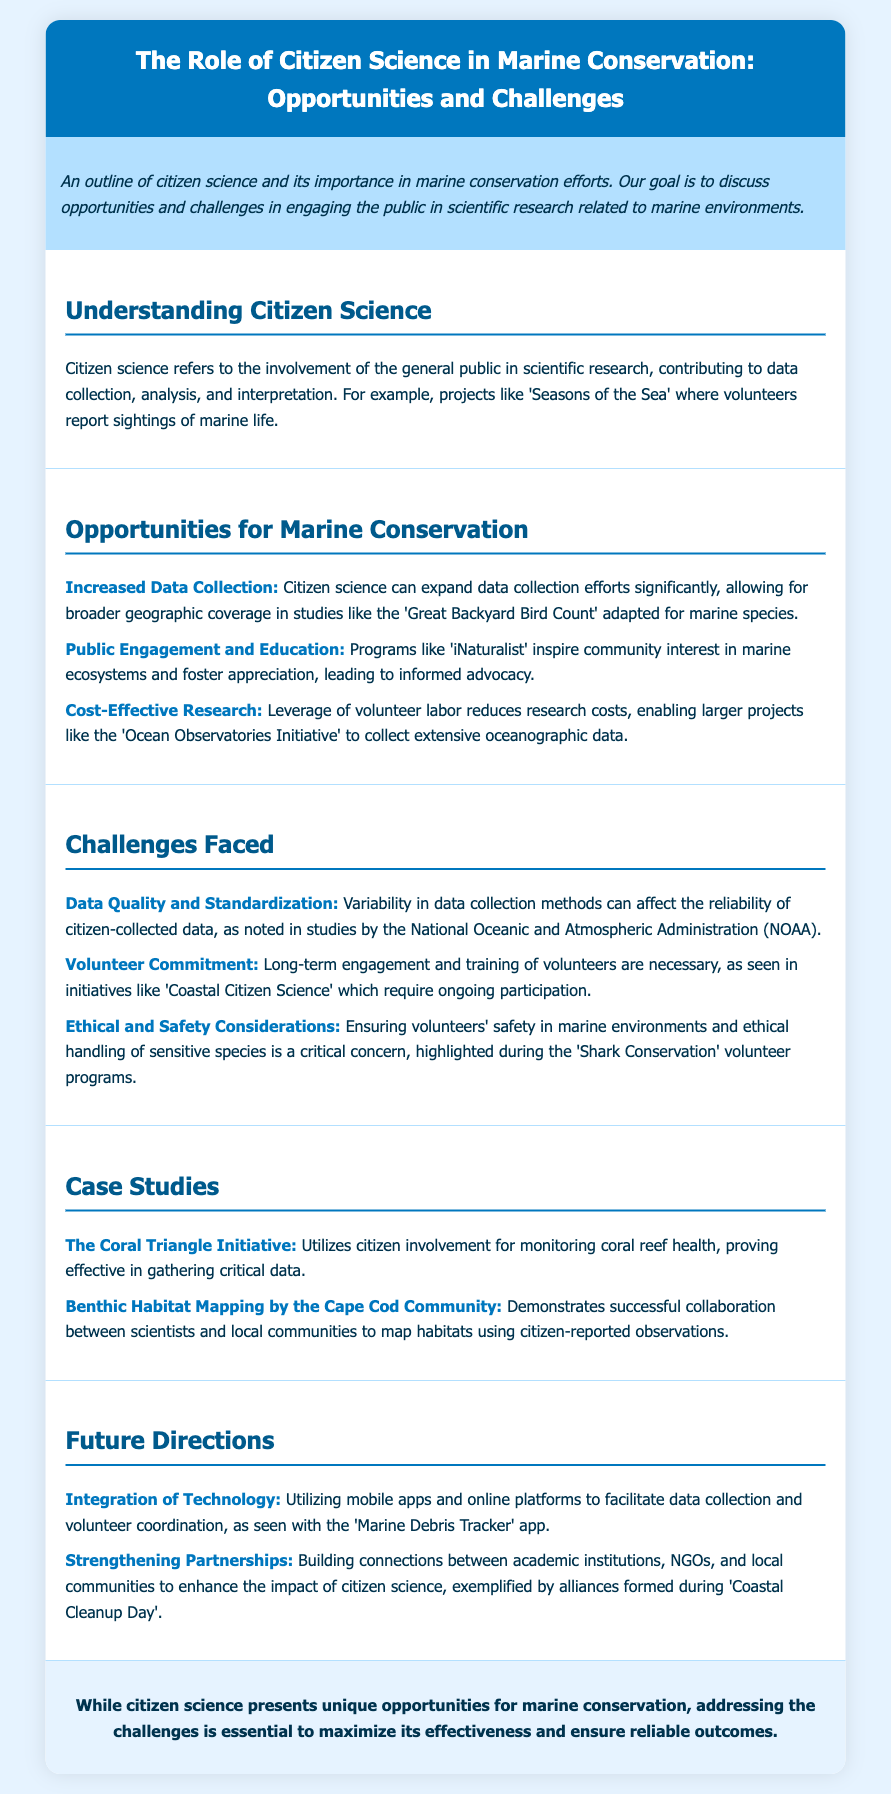What is the title of the document? The title is explicitly stated at the top of the document as "The Role of Citizen Science in Marine Conservation: Opportunities and Challenges."
Answer: The Role of Citizen Science in Marine Conservation: Opportunities and Challenges What is citizen science? The document defines citizen science as the involvement of the general public in scientific research, contributing to data collection, analysis, and interpretation.
Answer: Involvement of the general public in scientific research What are two benefits of citizen science mentioned? The document lists multiple benefits including Increased Data Collection, Public Engagement and Education, and Cost-Effective Research; two are requested.
Answer: Increased Data Collection, Public Engagement and Education Which initiative is highlighted for data quality concerns? The document specifically mentions the National Oceanic and Atmospheric Administration (NOAA) regarding data quality variability in citizen-collected data.
Answer: National Oceanic and Atmospheric Administration (NOAA) What is one case study about marine conservation? The Coral Triangle Initiative is mentioned as a successful example of citizen involvement for monitoring coral reef health.
Answer: The Coral Triangle Initiative What is an example of a future direction for citizen science? The document discusses utilizing mobile apps and online platforms to enhance data collection and volunteer coordination as a future direction.
Answer: Integration of Technology How does citizen science contribute to cost-effectiveness in research? The document states that leveraging volunteer labor reduces research costs, enabling larger projects to collect extensive data.
Answer: Leverage of volunteer labor reduces research costs What is a critical ethical consideration mentioned in the document? The document emphasizes ensuring volunteers' safety in marine environments and the ethical handling of sensitive species as a crucial ethical concern.
Answer: Ensuring volunteers' safety What program is referenced for public engagement in marine ecosystems? The document mentions 'iNaturalist' as a program that inspires community interest in marine ecosystems and fosters appreciation.
Answer: iNaturalist 